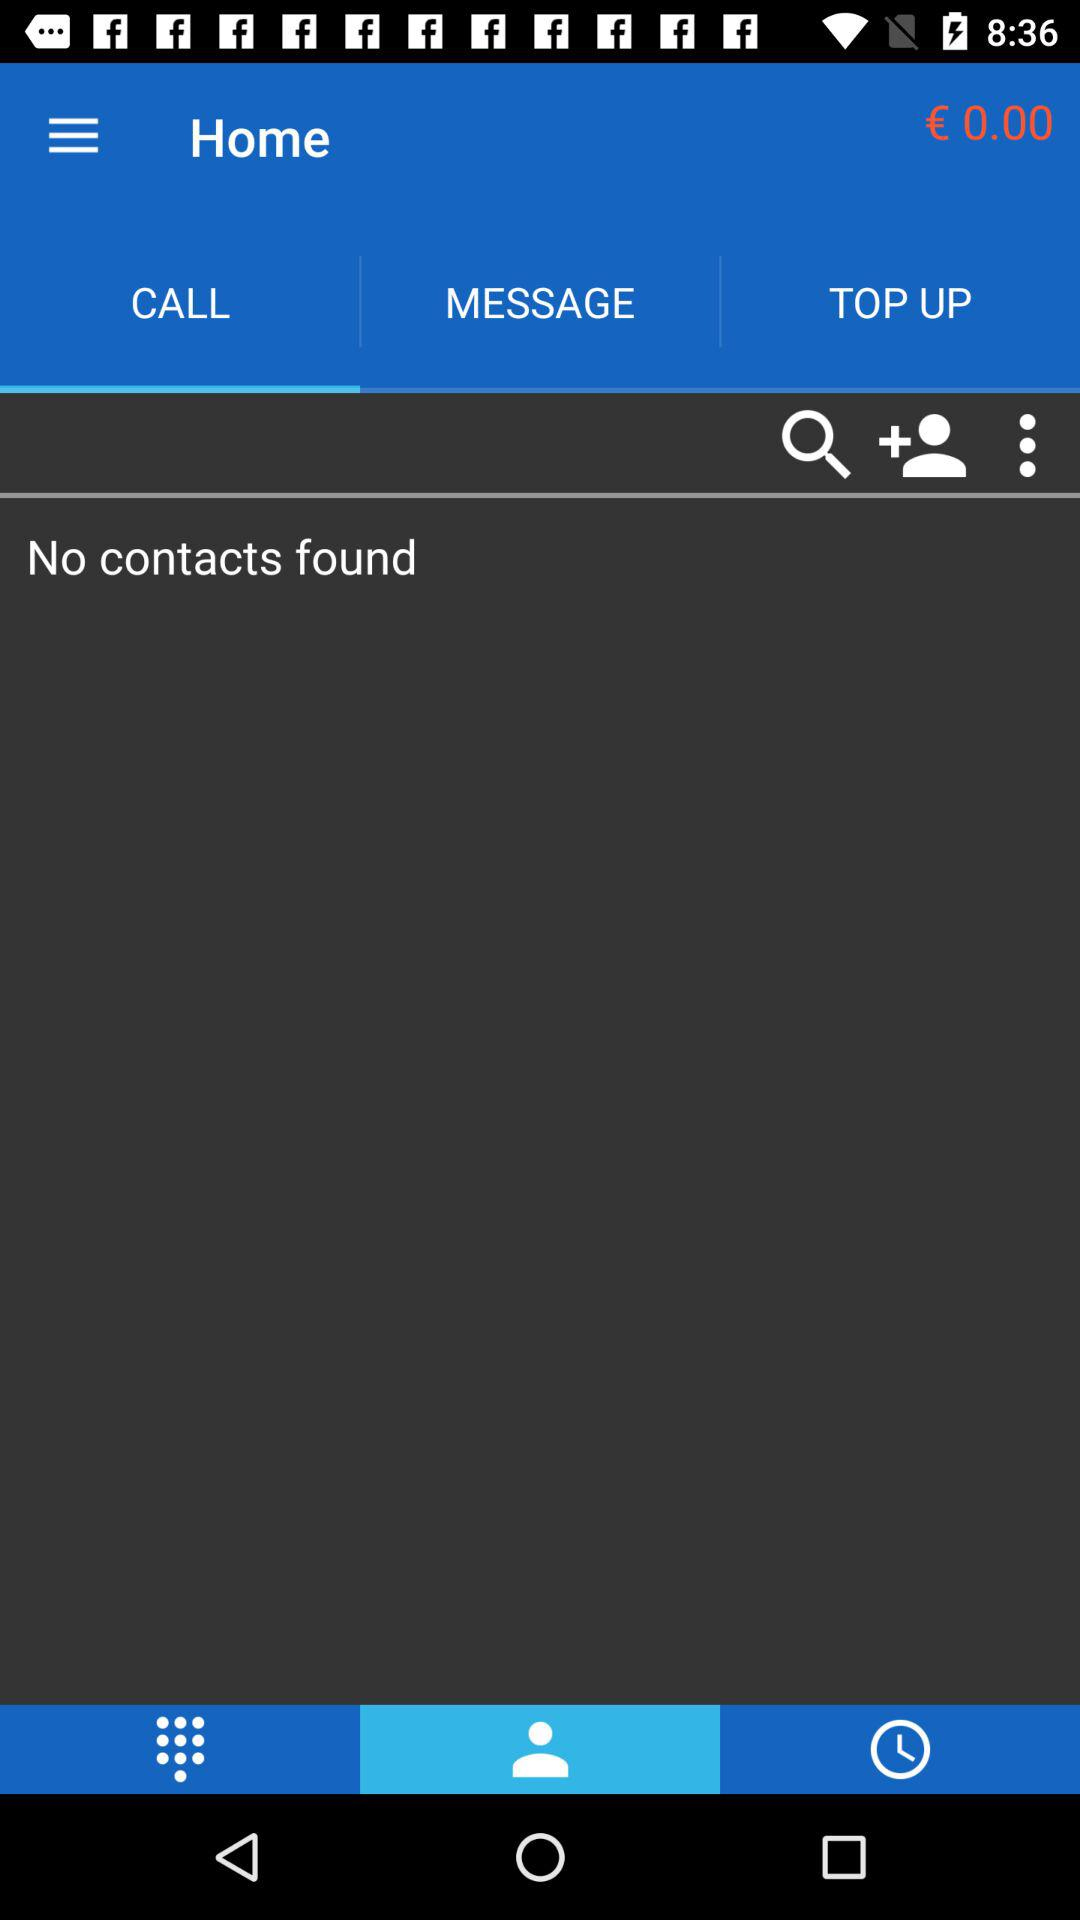How much balance is shown? The shown balance is € 0.00. 